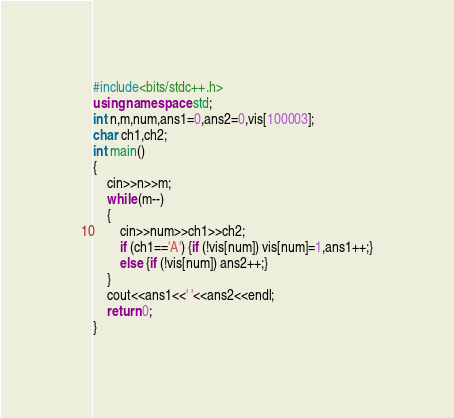Convert code to text. <code><loc_0><loc_0><loc_500><loc_500><_C++_>#include<bits/stdc++.h>
using namespace std;
int n,m,num,ans1=0,ans2=0,vis[100003];
char ch1,ch2;
int main()
{
	cin>>n>>m;
	while (m--)
	{
		cin>>num>>ch1>>ch2;
		if (ch1=='A') {if (!vis[num]) vis[num]=1,ans1++;}
		else {if (!vis[num]) ans2++;}
	}
	cout<<ans1<<' '<<ans2<<endl;
	return 0;
}</code> 